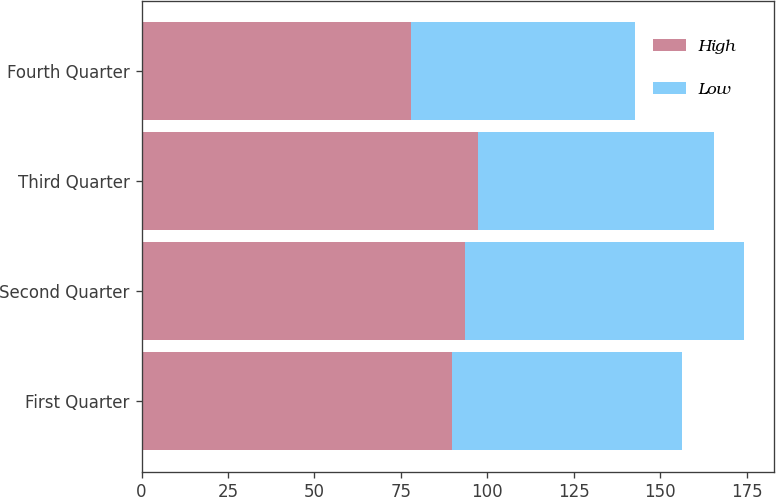Convert chart. <chart><loc_0><loc_0><loc_500><loc_500><stacked_bar_chart><ecel><fcel>First Quarter<fcel>Second Quarter<fcel>Third Quarter<fcel>Fourth Quarter<nl><fcel>High<fcel>89.69<fcel>93.63<fcel>97.19<fcel>77.8<nl><fcel>Low<fcel>66.54<fcel>80.54<fcel>68.29<fcel>64.9<nl></chart> 